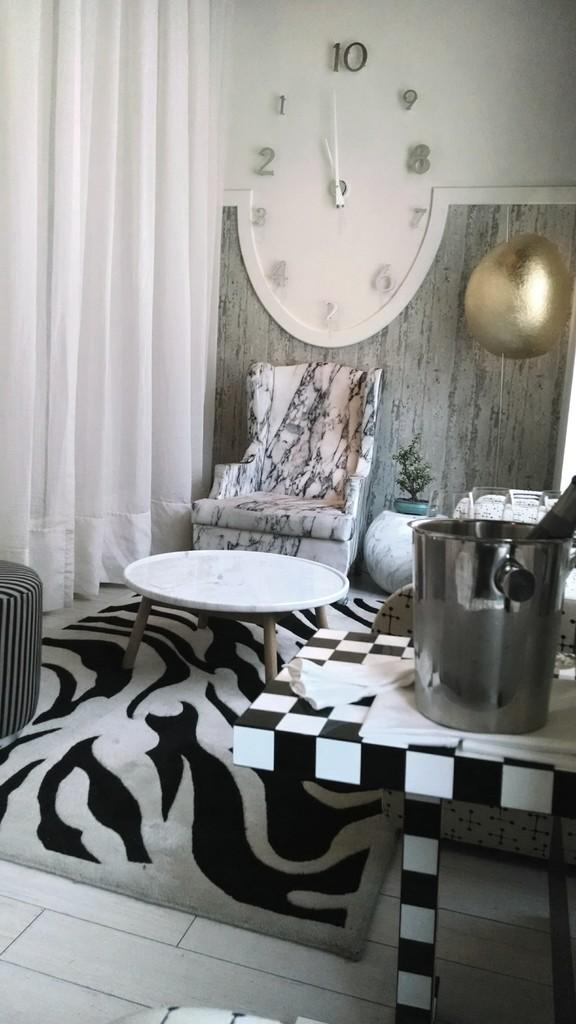<image>
Create a compact narrative representing the image presented. A room with a lot of black and white decorations and a large clock on the back wall with the numbers 1 through 10. 